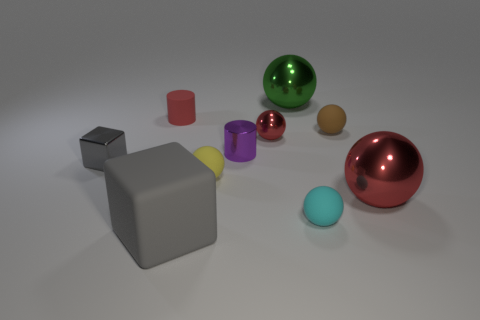What number of other things are there of the same size as the matte cylinder? Upon closely observing the rendered image, the matte red cylinder's size can be categorized as medium. Examining the size of other objects, we note the presence of larger objects like the large grey cube and the shiny red sphere, and smaller ones including the yellow cube and various small spheres. The only object sharing a similar size with the matte red cylinder is the medium glossy black cube. Thus, there is precisely one object in the image matching the size of the matte red cylinder. 